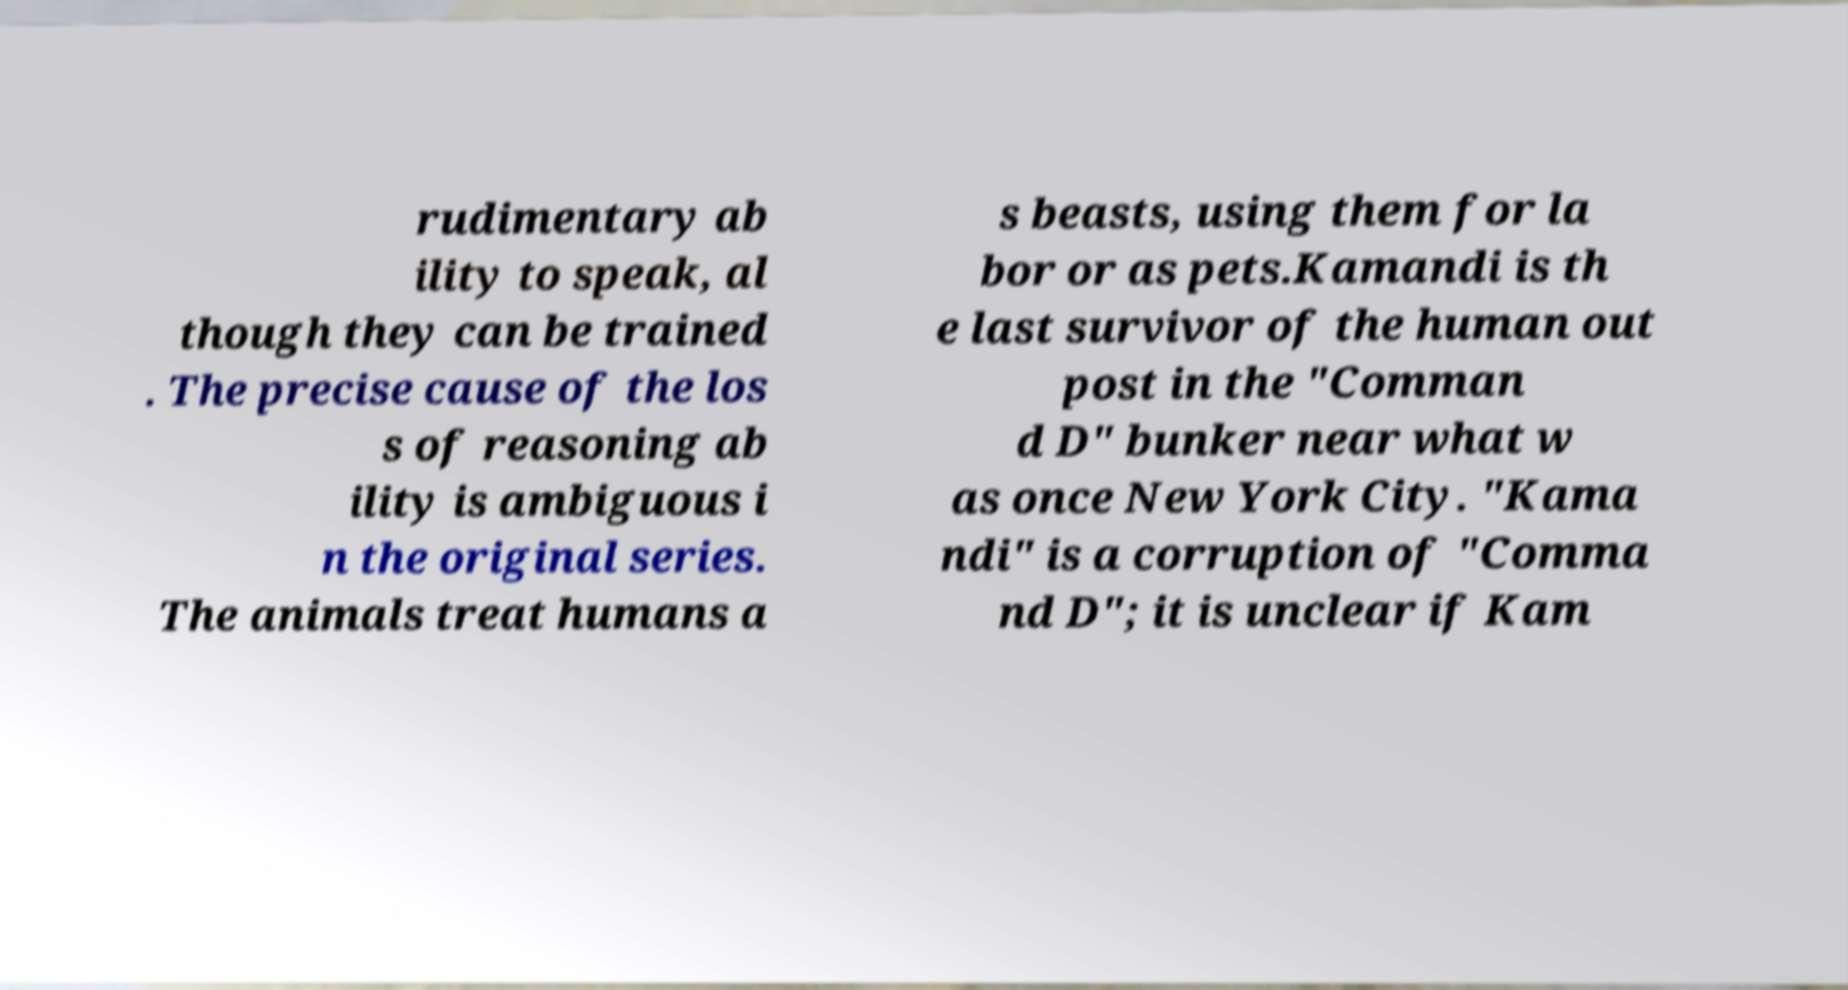What messages or text are displayed in this image? I need them in a readable, typed format. rudimentary ab ility to speak, al though they can be trained . The precise cause of the los s of reasoning ab ility is ambiguous i n the original series. The animals treat humans a s beasts, using them for la bor or as pets.Kamandi is th e last survivor of the human out post in the "Comman d D" bunker near what w as once New York City. "Kama ndi" is a corruption of "Comma nd D"; it is unclear if Kam 